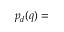<formula> <loc_0><loc_0><loc_500><loc_500>p _ { d } ( q ) =</formula> 